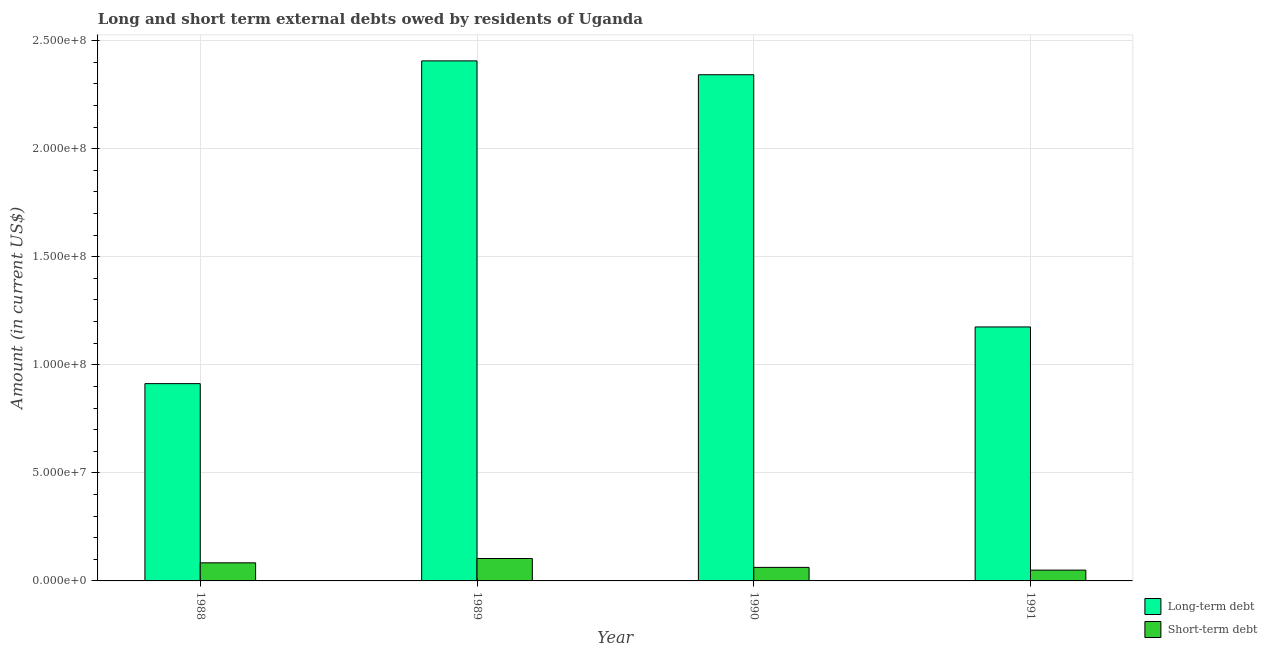How many different coloured bars are there?
Make the answer very short. 2. How many groups of bars are there?
Ensure brevity in your answer.  4. Are the number of bars per tick equal to the number of legend labels?
Give a very brief answer. Yes. Are the number of bars on each tick of the X-axis equal?
Offer a very short reply. Yes. How many bars are there on the 2nd tick from the right?
Ensure brevity in your answer.  2. What is the label of the 1st group of bars from the left?
Your answer should be very brief. 1988. In how many cases, is the number of bars for a given year not equal to the number of legend labels?
Your response must be concise. 0. What is the short-term debts owed by residents in 1991?
Ensure brevity in your answer.  5.00e+06. Across all years, what is the maximum long-term debts owed by residents?
Make the answer very short. 2.41e+08. Across all years, what is the minimum long-term debts owed by residents?
Provide a short and direct response. 9.13e+07. In which year was the short-term debts owed by residents minimum?
Offer a very short reply. 1991. What is the total short-term debts owed by residents in the graph?
Your answer should be compact. 3.00e+07. What is the difference between the long-term debts owed by residents in 1988 and that in 1990?
Your answer should be very brief. -1.43e+08. What is the difference between the short-term debts owed by residents in 1988 and the long-term debts owed by residents in 1989?
Your answer should be compact. -2.00e+06. What is the average long-term debts owed by residents per year?
Provide a short and direct response. 1.71e+08. In the year 1991, what is the difference between the long-term debts owed by residents and short-term debts owed by residents?
Offer a very short reply. 0. In how many years, is the short-term debts owed by residents greater than 30000000 US$?
Provide a succinct answer. 0. What is the ratio of the short-term debts owed by residents in 1988 to that in 1991?
Your answer should be very brief. 1.67. What is the difference between the highest and the second highest long-term debts owed by residents?
Provide a succinct answer. 6.41e+06. What is the difference between the highest and the lowest long-term debts owed by residents?
Make the answer very short. 1.49e+08. In how many years, is the short-term debts owed by residents greater than the average short-term debts owed by residents taken over all years?
Ensure brevity in your answer.  2. Is the sum of the short-term debts owed by residents in 1988 and 1991 greater than the maximum long-term debts owed by residents across all years?
Offer a terse response. Yes. What does the 2nd bar from the left in 1988 represents?
Keep it short and to the point. Short-term debt. What does the 1st bar from the right in 1988 represents?
Ensure brevity in your answer.  Short-term debt. How many years are there in the graph?
Give a very brief answer. 4. What is the difference between two consecutive major ticks on the Y-axis?
Ensure brevity in your answer.  5.00e+07. Are the values on the major ticks of Y-axis written in scientific E-notation?
Your answer should be very brief. Yes. Does the graph contain any zero values?
Ensure brevity in your answer.  No. Does the graph contain grids?
Give a very brief answer. Yes. How many legend labels are there?
Offer a terse response. 2. How are the legend labels stacked?
Your answer should be compact. Vertical. What is the title of the graph?
Offer a terse response. Long and short term external debts owed by residents of Uganda. What is the label or title of the Y-axis?
Make the answer very short. Amount (in current US$). What is the Amount (in current US$) of Long-term debt in 1988?
Offer a terse response. 9.13e+07. What is the Amount (in current US$) of Short-term debt in 1988?
Offer a terse response. 8.37e+06. What is the Amount (in current US$) in Long-term debt in 1989?
Ensure brevity in your answer.  2.41e+08. What is the Amount (in current US$) in Short-term debt in 1989?
Ensure brevity in your answer.  1.04e+07. What is the Amount (in current US$) of Long-term debt in 1990?
Make the answer very short. 2.34e+08. What is the Amount (in current US$) of Short-term debt in 1990?
Your response must be concise. 6.26e+06. What is the Amount (in current US$) in Long-term debt in 1991?
Make the answer very short. 1.18e+08. What is the Amount (in current US$) in Short-term debt in 1991?
Provide a short and direct response. 5.00e+06. Across all years, what is the maximum Amount (in current US$) of Long-term debt?
Keep it short and to the point. 2.41e+08. Across all years, what is the maximum Amount (in current US$) of Short-term debt?
Offer a terse response. 1.04e+07. Across all years, what is the minimum Amount (in current US$) of Long-term debt?
Offer a very short reply. 9.13e+07. Across all years, what is the minimum Amount (in current US$) of Short-term debt?
Your answer should be very brief. 5.00e+06. What is the total Amount (in current US$) in Long-term debt in the graph?
Your response must be concise. 6.84e+08. What is the total Amount (in current US$) of Short-term debt in the graph?
Make the answer very short. 3.00e+07. What is the difference between the Amount (in current US$) of Long-term debt in 1988 and that in 1989?
Offer a very short reply. -1.49e+08. What is the difference between the Amount (in current US$) of Long-term debt in 1988 and that in 1990?
Keep it short and to the point. -1.43e+08. What is the difference between the Amount (in current US$) in Short-term debt in 1988 and that in 1990?
Your answer should be very brief. 2.11e+06. What is the difference between the Amount (in current US$) in Long-term debt in 1988 and that in 1991?
Offer a very short reply. -2.62e+07. What is the difference between the Amount (in current US$) in Short-term debt in 1988 and that in 1991?
Your response must be concise. 3.37e+06. What is the difference between the Amount (in current US$) of Long-term debt in 1989 and that in 1990?
Your answer should be very brief. 6.41e+06. What is the difference between the Amount (in current US$) in Short-term debt in 1989 and that in 1990?
Your answer should be very brief. 4.11e+06. What is the difference between the Amount (in current US$) of Long-term debt in 1989 and that in 1991?
Offer a terse response. 1.23e+08. What is the difference between the Amount (in current US$) of Short-term debt in 1989 and that in 1991?
Provide a succinct answer. 5.37e+06. What is the difference between the Amount (in current US$) of Long-term debt in 1990 and that in 1991?
Your answer should be compact. 1.17e+08. What is the difference between the Amount (in current US$) in Short-term debt in 1990 and that in 1991?
Provide a succinct answer. 1.26e+06. What is the difference between the Amount (in current US$) in Long-term debt in 1988 and the Amount (in current US$) in Short-term debt in 1989?
Your answer should be compact. 8.09e+07. What is the difference between the Amount (in current US$) in Long-term debt in 1988 and the Amount (in current US$) in Short-term debt in 1990?
Ensure brevity in your answer.  8.50e+07. What is the difference between the Amount (in current US$) of Long-term debt in 1988 and the Amount (in current US$) of Short-term debt in 1991?
Provide a short and direct response. 8.63e+07. What is the difference between the Amount (in current US$) of Long-term debt in 1989 and the Amount (in current US$) of Short-term debt in 1990?
Your response must be concise. 2.34e+08. What is the difference between the Amount (in current US$) of Long-term debt in 1989 and the Amount (in current US$) of Short-term debt in 1991?
Offer a terse response. 2.36e+08. What is the difference between the Amount (in current US$) in Long-term debt in 1990 and the Amount (in current US$) in Short-term debt in 1991?
Give a very brief answer. 2.29e+08. What is the average Amount (in current US$) in Long-term debt per year?
Your response must be concise. 1.71e+08. What is the average Amount (in current US$) in Short-term debt per year?
Offer a very short reply. 7.50e+06. In the year 1988, what is the difference between the Amount (in current US$) of Long-term debt and Amount (in current US$) of Short-term debt?
Keep it short and to the point. 8.29e+07. In the year 1989, what is the difference between the Amount (in current US$) of Long-term debt and Amount (in current US$) of Short-term debt?
Your answer should be very brief. 2.30e+08. In the year 1990, what is the difference between the Amount (in current US$) of Long-term debt and Amount (in current US$) of Short-term debt?
Provide a succinct answer. 2.28e+08. In the year 1991, what is the difference between the Amount (in current US$) in Long-term debt and Amount (in current US$) in Short-term debt?
Ensure brevity in your answer.  1.13e+08. What is the ratio of the Amount (in current US$) in Long-term debt in 1988 to that in 1989?
Provide a short and direct response. 0.38. What is the ratio of the Amount (in current US$) of Short-term debt in 1988 to that in 1989?
Make the answer very short. 0.81. What is the ratio of the Amount (in current US$) of Long-term debt in 1988 to that in 1990?
Your answer should be very brief. 0.39. What is the ratio of the Amount (in current US$) of Short-term debt in 1988 to that in 1990?
Your response must be concise. 1.34. What is the ratio of the Amount (in current US$) in Long-term debt in 1988 to that in 1991?
Keep it short and to the point. 0.78. What is the ratio of the Amount (in current US$) of Short-term debt in 1988 to that in 1991?
Your answer should be very brief. 1.67. What is the ratio of the Amount (in current US$) in Long-term debt in 1989 to that in 1990?
Your answer should be compact. 1.03. What is the ratio of the Amount (in current US$) of Short-term debt in 1989 to that in 1990?
Give a very brief answer. 1.66. What is the ratio of the Amount (in current US$) in Long-term debt in 1989 to that in 1991?
Make the answer very short. 2.05. What is the ratio of the Amount (in current US$) in Short-term debt in 1989 to that in 1991?
Give a very brief answer. 2.07. What is the ratio of the Amount (in current US$) in Long-term debt in 1990 to that in 1991?
Your answer should be very brief. 1.99. What is the ratio of the Amount (in current US$) of Short-term debt in 1990 to that in 1991?
Provide a succinct answer. 1.25. What is the difference between the highest and the second highest Amount (in current US$) of Long-term debt?
Offer a very short reply. 6.41e+06. What is the difference between the highest and the lowest Amount (in current US$) of Long-term debt?
Offer a terse response. 1.49e+08. What is the difference between the highest and the lowest Amount (in current US$) of Short-term debt?
Provide a short and direct response. 5.37e+06. 